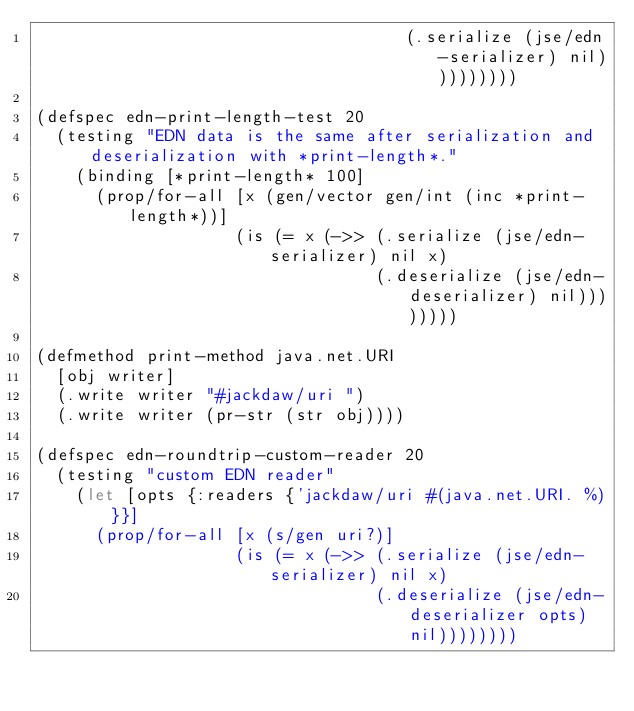<code> <loc_0><loc_0><loc_500><loc_500><_Clojure_>                                     (.serialize (jse/edn-serializer) nil)))))))))

(defspec edn-print-length-test 20
  (testing "EDN data is the same after serialization and deserialization with *print-length*."
    (binding [*print-length* 100]
      (prop/for-all [x (gen/vector gen/int (inc *print-length*))]
                    (is (= x (->> (.serialize (jse/edn-serializer) nil x)
                                  (.deserialize (jse/edn-deserializer) nil))))))))

(defmethod print-method java.net.URI
  [obj writer]
  (.write writer "#jackdaw/uri ")
  (.write writer (pr-str (str obj))))

(defspec edn-roundtrip-custom-reader 20
  (testing "custom EDN reader"
    (let [opts {:readers {'jackdaw/uri #(java.net.URI. %)}}]
      (prop/for-all [x (s/gen uri?)]
                    (is (= x (->> (.serialize (jse/edn-serializer) nil x)
                                  (.deserialize (jse/edn-deserializer opts) nil))))))))
</code> 